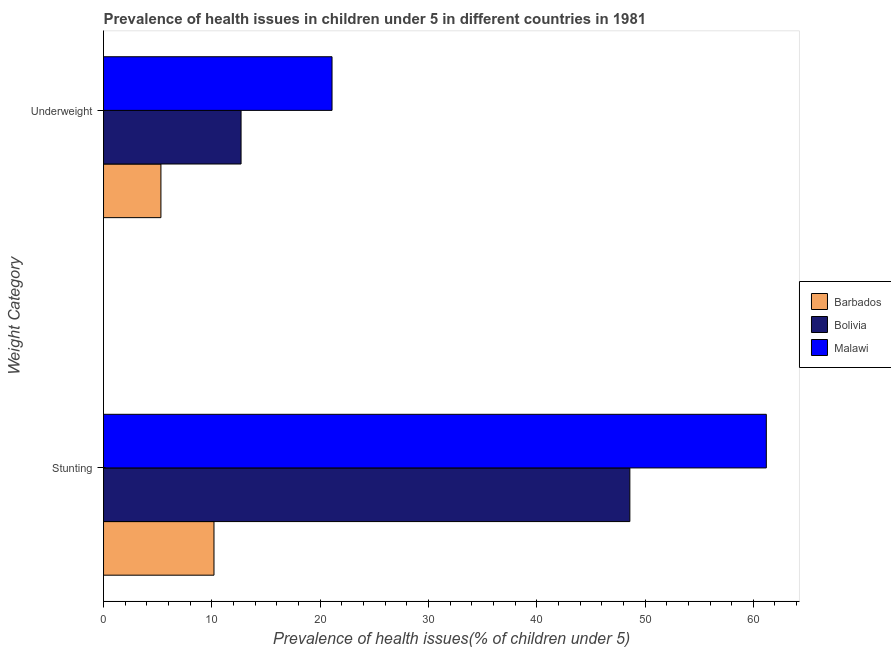How many different coloured bars are there?
Your answer should be very brief. 3. How many groups of bars are there?
Offer a very short reply. 2. Are the number of bars per tick equal to the number of legend labels?
Offer a terse response. Yes. How many bars are there on the 1st tick from the top?
Offer a terse response. 3. How many bars are there on the 2nd tick from the bottom?
Your response must be concise. 3. What is the label of the 1st group of bars from the top?
Keep it short and to the point. Underweight. What is the percentage of underweight children in Bolivia?
Give a very brief answer. 12.7. Across all countries, what is the maximum percentage of underweight children?
Your answer should be very brief. 21.1. Across all countries, what is the minimum percentage of underweight children?
Your answer should be compact. 5.3. In which country was the percentage of stunted children maximum?
Provide a succinct answer. Malawi. In which country was the percentage of stunted children minimum?
Make the answer very short. Barbados. What is the total percentage of stunted children in the graph?
Your answer should be very brief. 120. What is the difference between the percentage of stunted children in Bolivia and that in Barbados?
Provide a short and direct response. 38.4. What is the difference between the percentage of underweight children in Bolivia and the percentage of stunted children in Malawi?
Your response must be concise. -48.5. What is the average percentage of underweight children per country?
Ensure brevity in your answer.  13.03. What is the difference between the percentage of stunted children and percentage of underweight children in Bolivia?
Offer a very short reply. 35.9. What is the ratio of the percentage of underweight children in Malawi to that in Barbados?
Your answer should be compact. 3.98. In how many countries, is the percentage of underweight children greater than the average percentage of underweight children taken over all countries?
Keep it short and to the point. 1. What does the 3rd bar from the top in Stunting represents?
Your answer should be compact. Barbados. How many bars are there?
Give a very brief answer. 6. How many countries are there in the graph?
Provide a succinct answer. 3. What is the difference between two consecutive major ticks on the X-axis?
Offer a very short reply. 10. Does the graph contain any zero values?
Your answer should be very brief. No. Does the graph contain grids?
Provide a succinct answer. No. How are the legend labels stacked?
Offer a terse response. Vertical. What is the title of the graph?
Ensure brevity in your answer.  Prevalence of health issues in children under 5 in different countries in 1981. Does "Turkey" appear as one of the legend labels in the graph?
Provide a short and direct response. No. What is the label or title of the X-axis?
Give a very brief answer. Prevalence of health issues(% of children under 5). What is the label or title of the Y-axis?
Your response must be concise. Weight Category. What is the Prevalence of health issues(% of children under 5) of Barbados in Stunting?
Make the answer very short. 10.2. What is the Prevalence of health issues(% of children under 5) of Bolivia in Stunting?
Your response must be concise. 48.6. What is the Prevalence of health issues(% of children under 5) in Malawi in Stunting?
Provide a succinct answer. 61.2. What is the Prevalence of health issues(% of children under 5) in Barbados in Underweight?
Ensure brevity in your answer.  5.3. What is the Prevalence of health issues(% of children under 5) in Bolivia in Underweight?
Provide a succinct answer. 12.7. What is the Prevalence of health issues(% of children under 5) of Malawi in Underweight?
Give a very brief answer. 21.1. Across all Weight Category, what is the maximum Prevalence of health issues(% of children under 5) in Barbados?
Your response must be concise. 10.2. Across all Weight Category, what is the maximum Prevalence of health issues(% of children under 5) in Bolivia?
Your answer should be very brief. 48.6. Across all Weight Category, what is the maximum Prevalence of health issues(% of children under 5) of Malawi?
Offer a terse response. 61.2. Across all Weight Category, what is the minimum Prevalence of health issues(% of children under 5) of Barbados?
Ensure brevity in your answer.  5.3. Across all Weight Category, what is the minimum Prevalence of health issues(% of children under 5) of Bolivia?
Your response must be concise. 12.7. Across all Weight Category, what is the minimum Prevalence of health issues(% of children under 5) in Malawi?
Keep it short and to the point. 21.1. What is the total Prevalence of health issues(% of children under 5) of Bolivia in the graph?
Provide a succinct answer. 61.3. What is the total Prevalence of health issues(% of children under 5) in Malawi in the graph?
Your answer should be compact. 82.3. What is the difference between the Prevalence of health issues(% of children under 5) in Bolivia in Stunting and that in Underweight?
Keep it short and to the point. 35.9. What is the difference between the Prevalence of health issues(% of children under 5) in Malawi in Stunting and that in Underweight?
Your response must be concise. 40.1. What is the difference between the Prevalence of health issues(% of children under 5) of Barbados in Stunting and the Prevalence of health issues(% of children under 5) of Bolivia in Underweight?
Keep it short and to the point. -2.5. What is the difference between the Prevalence of health issues(% of children under 5) in Bolivia in Stunting and the Prevalence of health issues(% of children under 5) in Malawi in Underweight?
Your answer should be compact. 27.5. What is the average Prevalence of health issues(% of children under 5) of Barbados per Weight Category?
Offer a terse response. 7.75. What is the average Prevalence of health issues(% of children under 5) of Bolivia per Weight Category?
Ensure brevity in your answer.  30.65. What is the average Prevalence of health issues(% of children under 5) of Malawi per Weight Category?
Give a very brief answer. 41.15. What is the difference between the Prevalence of health issues(% of children under 5) in Barbados and Prevalence of health issues(% of children under 5) in Bolivia in Stunting?
Your answer should be compact. -38.4. What is the difference between the Prevalence of health issues(% of children under 5) in Barbados and Prevalence of health issues(% of children under 5) in Malawi in Stunting?
Give a very brief answer. -51. What is the difference between the Prevalence of health issues(% of children under 5) in Bolivia and Prevalence of health issues(% of children under 5) in Malawi in Stunting?
Make the answer very short. -12.6. What is the difference between the Prevalence of health issues(% of children under 5) of Barbados and Prevalence of health issues(% of children under 5) of Malawi in Underweight?
Your answer should be very brief. -15.8. What is the ratio of the Prevalence of health issues(% of children under 5) of Barbados in Stunting to that in Underweight?
Keep it short and to the point. 1.92. What is the ratio of the Prevalence of health issues(% of children under 5) in Bolivia in Stunting to that in Underweight?
Your answer should be compact. 3.83. What is the ratio of the Prevalence of health issues(% of children under 5) in Malawi in Stunting to that in Underweight?
Ensure brevity in your answer.  2.9. What is the difference between the highest and the second highest Prevalence of health issues(% of children under 5) of Bolivia?
Offer a terse response. 35.9. What is the difference between the highest and the second highest Prevalence of health issues(% of children under 5) of Malawi?
Make the answer very short. 40.1. What is the difference between the highest and the lowest Prevalence of health issues(% of children under 5) of Bolivia?
Make the answer very short. 35.9. What is the difference between the highest and the lowest Prevalence of health issues(% of children under 5) of Malawi?
Ensure brevity in your answer.  40.1. 